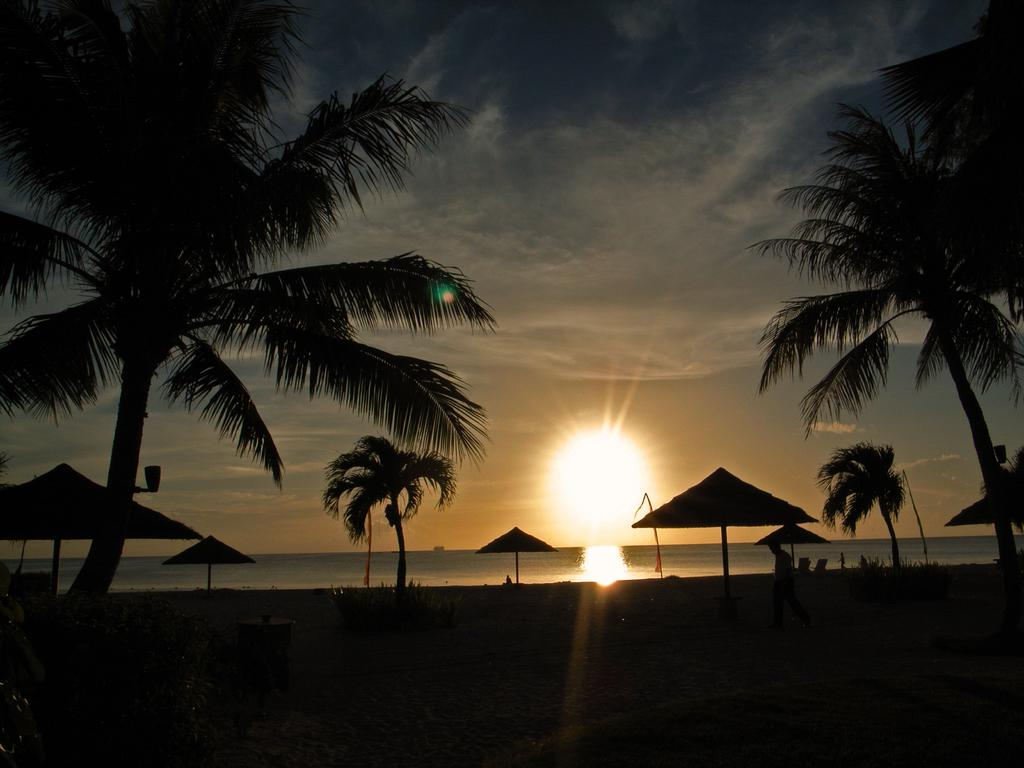What type of vegetation is present in the image? There are trees in the image. What objects are visible in the image that might provide shade? There are umbrellas in the image. Can you describe the person in the image? There is a person in the image. What can be seen in the background of the image? There is water and the sun visible in the background of the image. How would you describe the lighting in the image? The image appears to be a bit dark. What type of butter is being used for arithmetic in the image? There is no butter or arithmetic present in the image. What is the person in the image trying to burn? There is no indication of a person attempting to burn anything in the image. 